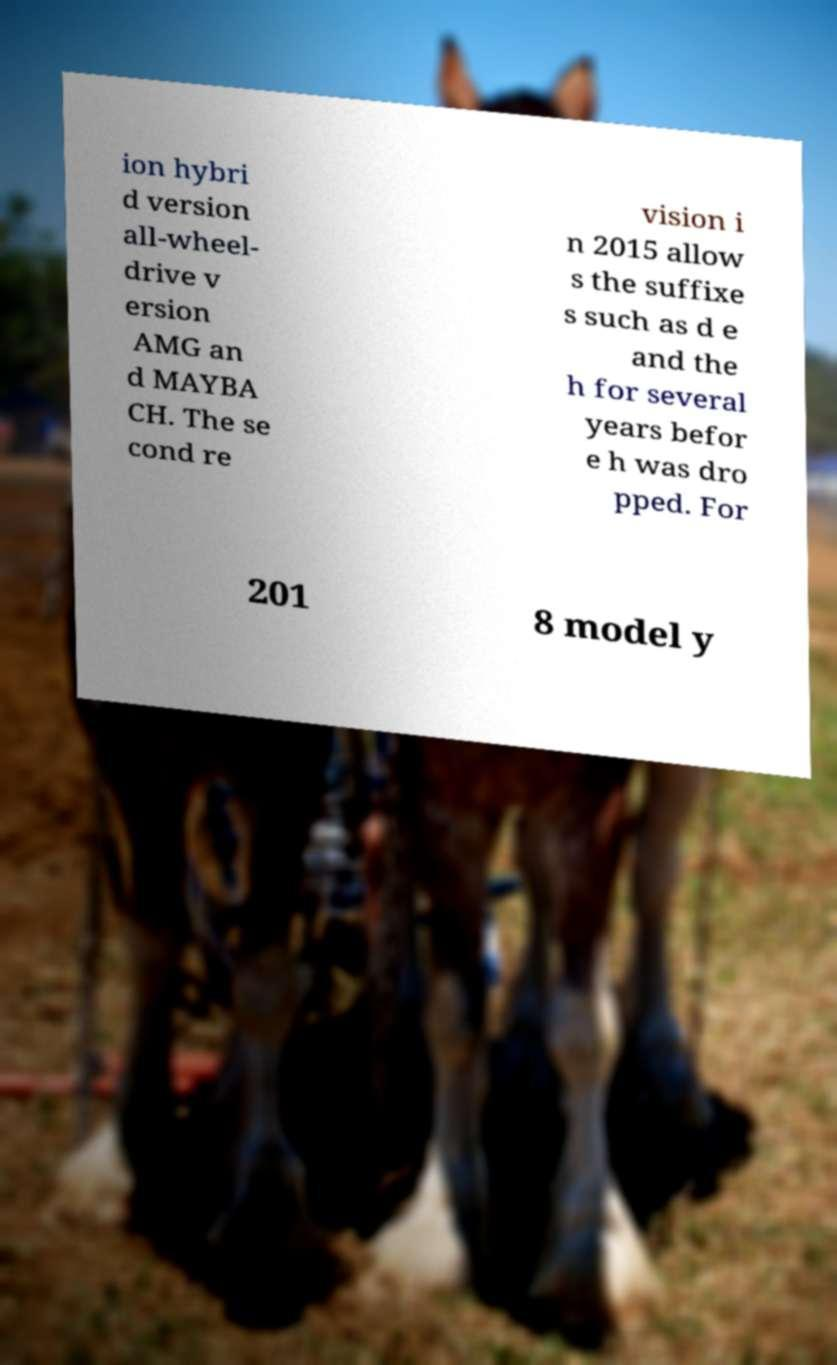Could you assist in decoding the text presented in this image and type it out clearly? ion hybri d version all-wheel- drive v ersion AMG an d MAYBA CH. The se cond re vision i n 2015 allow s the suffixe s such as d e and the h for several years befor e h was dro pped. For 201 8 model y 